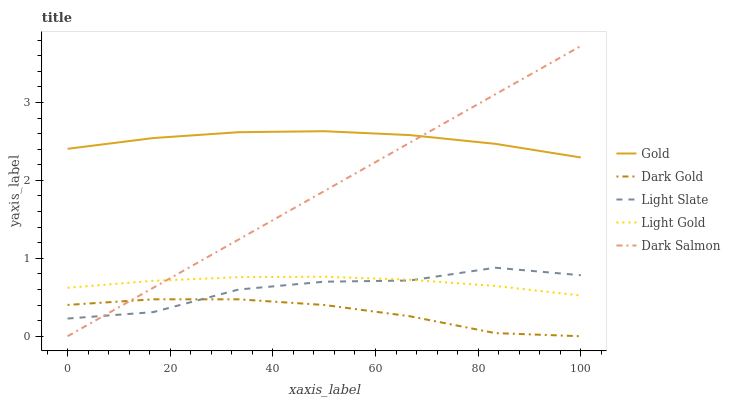Does Light Gold have the minimum area under the curve?
Answer yes or no. No. Does Light Gold have the maximum area under the curve?
Answer yes or no. No. Is Light Gold the smoothest?
Answer yes or no. No. Is Light Gold the roughest?
Answer yes or no. No. Does Light Gold have the lowest value?
Answer yes or no. No. Does Light Gold have the highest value?
Answer yes or no. No. Is Light Gold less than Gold?
Answer yes or no. Yes. Is Gold greater than Light Gold?
Answer yes or no. Yes. Does Light Gold intersect Gold?
Answer yes or no. No. 